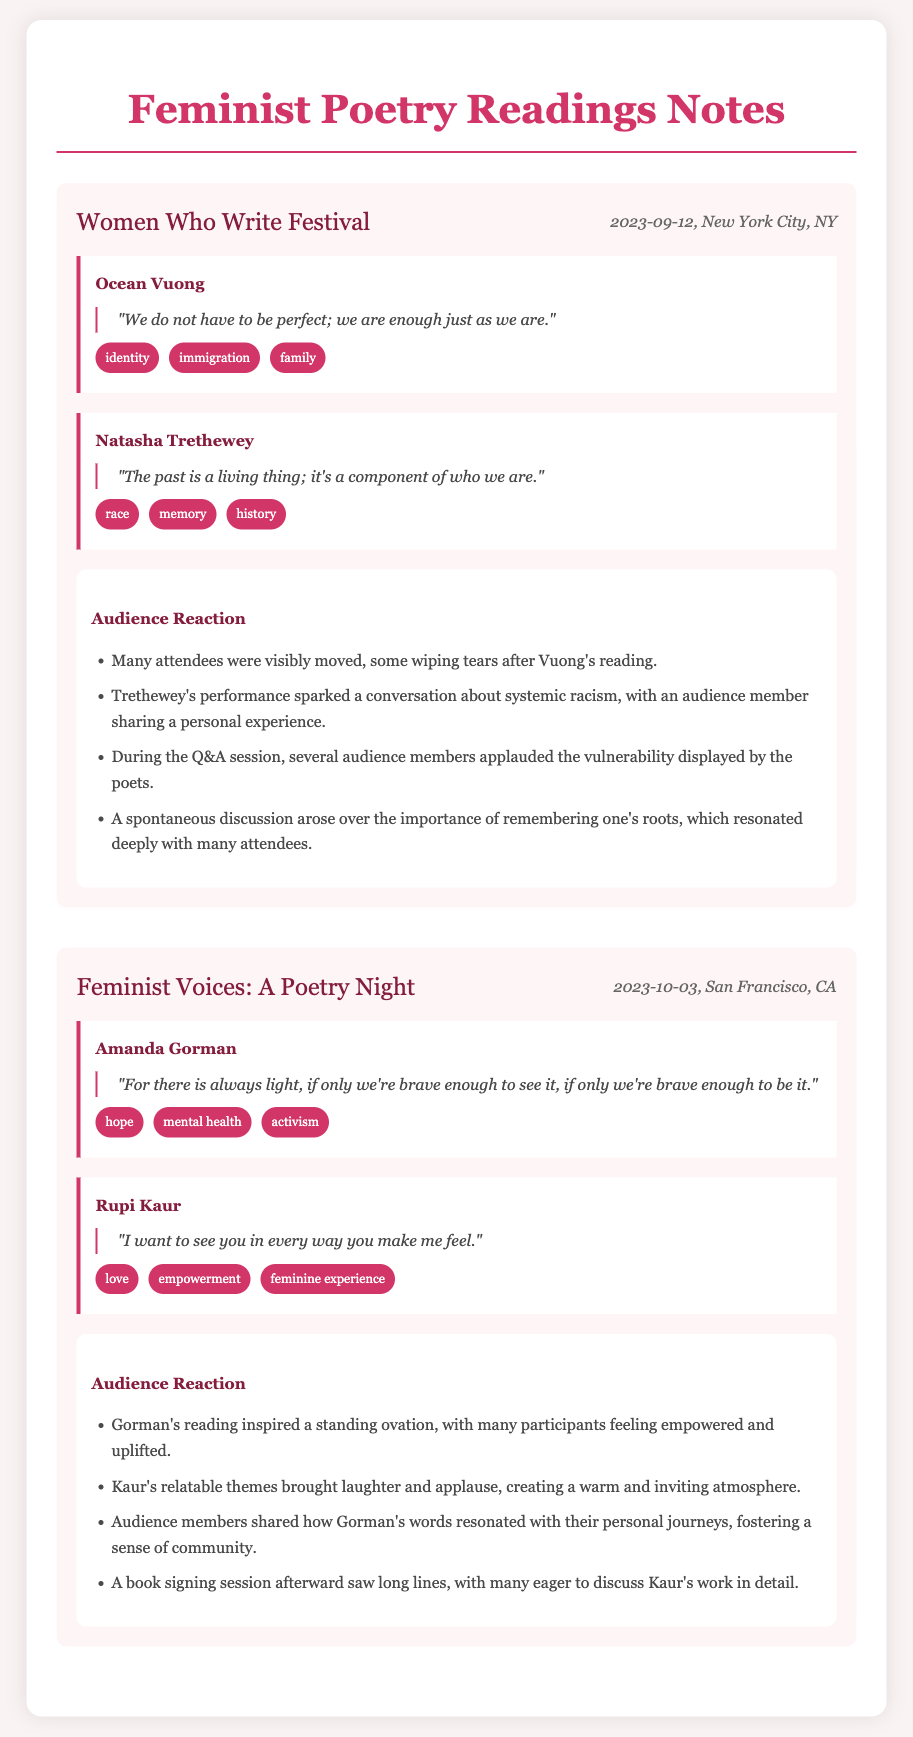what was the date of the Women Who Write Festival? The date of the event is clearly stated in the document.
Answer: 2023-09-12 who performed at the Feminist Voices: A Poetry Night? The document lists the poets who performed at this event.
Answer: Amanda Gorman, Rupi Kaur what theme did Ocean Vuong address in his poetry? The document mentions specific themes associated with each poet.
Answer: identity, immigration, family how did the audience react to Amanda Gorman's reading? The audience reactions are summarized in the document.
Answer: inspired a standing ovation what quote did Natasha Trethewey share? The document includes specific quotes from the poets during their readings.
Answer: "The past is a living thing; it's a component of who we are." which poet's performance sparked a conversation about systemic racism? The document provides information on audience reactions related to each poet's performance.
Answer: Natasha Trethewey how many themes are associated with Rupi Kaur's poetry? The document lists themes related to Rupi Kaur’s poetry.
Answer: three what notable event occurred after Kaur's reading? The document mentions activities that followed the readings.
Answer: book signing session 